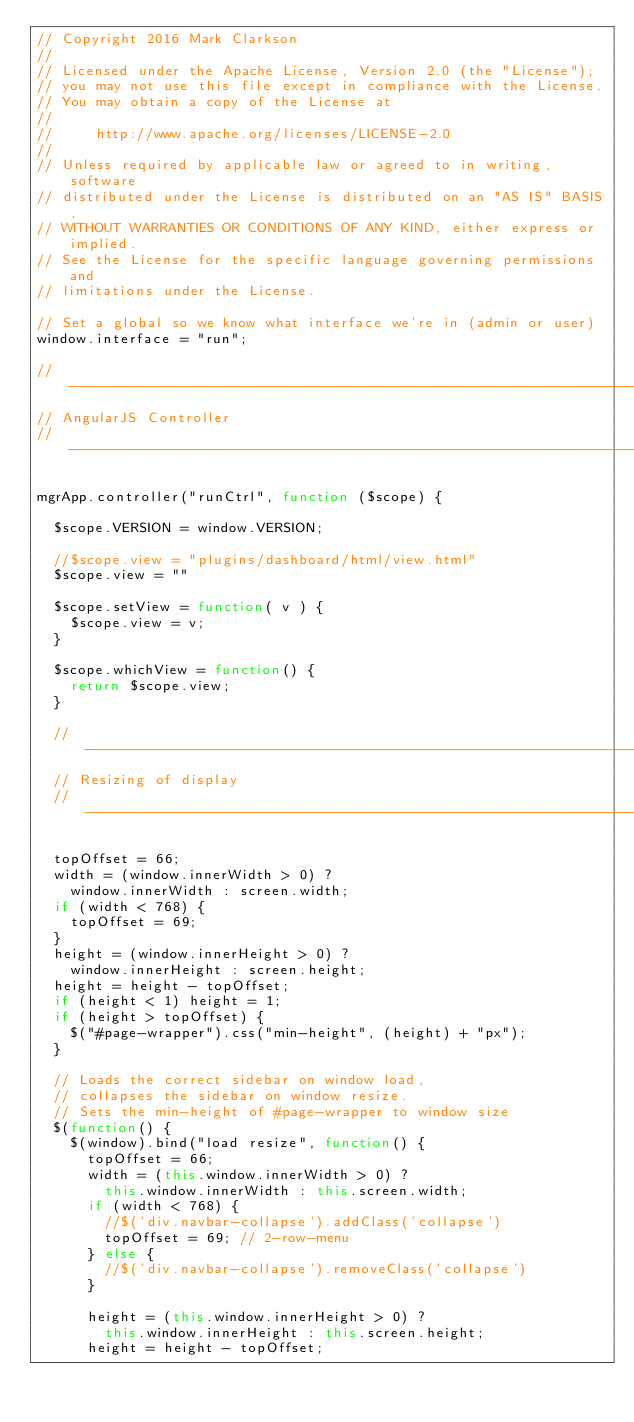Convert code to text. <code><loc_0><loc_0><loc_500><loc_500><_JavaScript_>// Copyright 2016 Mark Clarkson
//
// Licensed under the Apache License, Version 2.0 (the "License");
// you may not use this file except in compliance with the License.
// You may obtain a copy of the License at
//
//     http://www.apache.org/licenses/LICENSE-2.0
//
// Unless required by applicable law or agreed to in writing, software
// distributed under the License is distributed on an "AS IS" BASIS,
// WITHOUT WARRANTIES OR CONDITIONS OF ANY KIND, either express or implied.
// See the License for the specific language governing permissions and
// limitations under the License.

// Set a global so we know what interface we're in (admin or user)
window.interface = "run";

// ------------------------------------------------------------------------
// AngularJS Controller
// ------------------------------------------------------------------------

mgrApp.controller("runCtrl", function ($scope) {

	$scope.VERSION = window.VERSION;

  //$scope.view = "plugins/dashboard/html/view.html"
  $scope.view = ""

  $scope.setView = function( v ) {
    $scope.view = v;
  }

  $scope.whichView = function() {
    return $scope.view;
  }

  // ------------------------------------------------------------------------
  // Resizing of display
  // ------------------------------------------------------------------------

  topOffset = 66;
	width = (window.innerWidth > 0) ?
		window.innerWidth : screen.width;
	if (width < 768) {
		topOffset = 69;
	}
  height = (window.innerHeight > 0) ?
    window.innerHeight : screen.height;
  height = height - topOffset;
  if (height < 1) height = 1;
  if (height > topOffset) {
    $("#page-wrapper").css("min-height", (height) + "px");
  }

  // Loads the correct sidebar on window load,
  // collapses the sidebar on window resize.
  // Sets the min-height of #page-wrapper to window size
  $(function() {
    $(window).bind("load resize", function() {
      topOffset = 66;
      width = (this.window.innerWidth > 0) ?
        this.window.innerWidth : this.screen.width;
      if (width < 768) {
        //$('div.navbar-collapse').addClass('collapse')
        topOffset = 69; // 2-row-menu
      } else {
        //$('div.navbar-collapse').removeClass('collapse')
      }

      height = (this.window.innerHeight > 0) ?
        this.window.innerHeight : this.screen.height;
      height = height - topOffset;</code> 